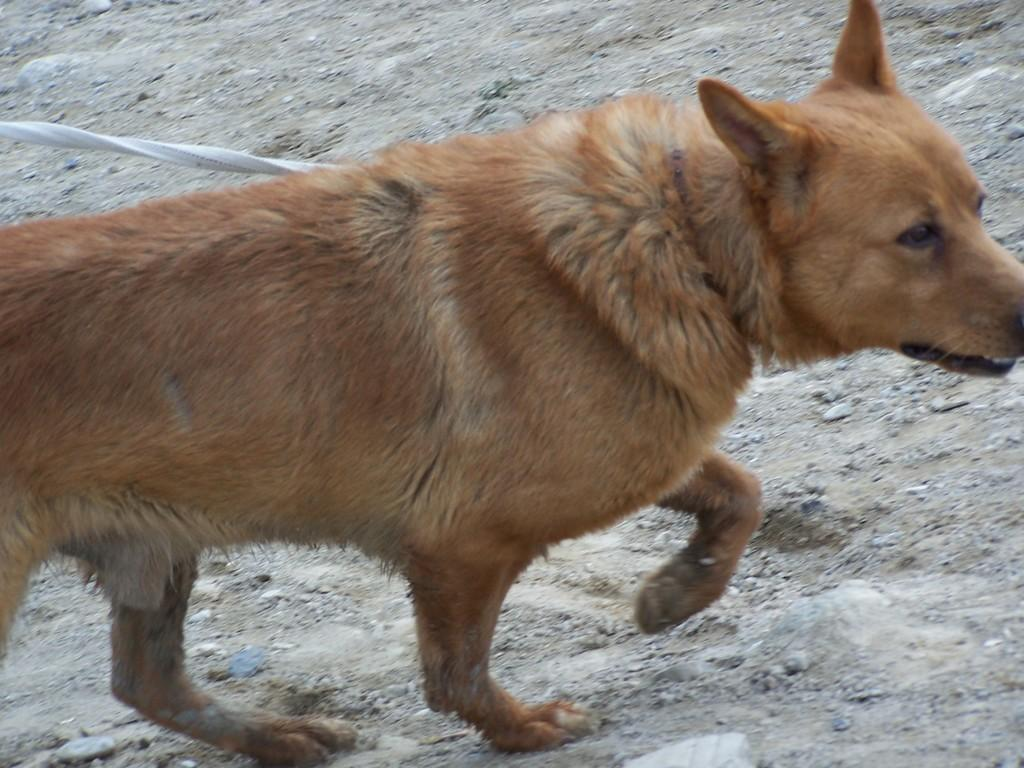What type of creature is present in the image? There is an animal in the image. Where is the animal located? The animal is on the ground. What other object can be seen in the image? There is a white color rope in the image. What type of ink is being used by the ducks in the image? There are: There are no ducks present in the image, and therefore no ink or writing can be observed. 